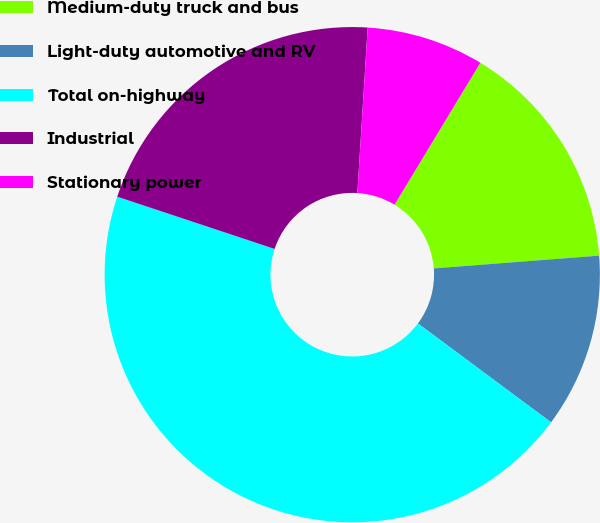Convert chart. <chart><loc_0><loc_0><loc_500><loc_500><pie_chart><fcel>Medium-duty truck and bus<fcel>Light-duty automotive and RV<fcel>Total on-highway<fcel>Industrial<fcel>Stationary power<nl><fcel>15.12%<fcel>11.39%<fcel>44.93%<fcel>20.89%<fcel>7.66%<nl></chart> 